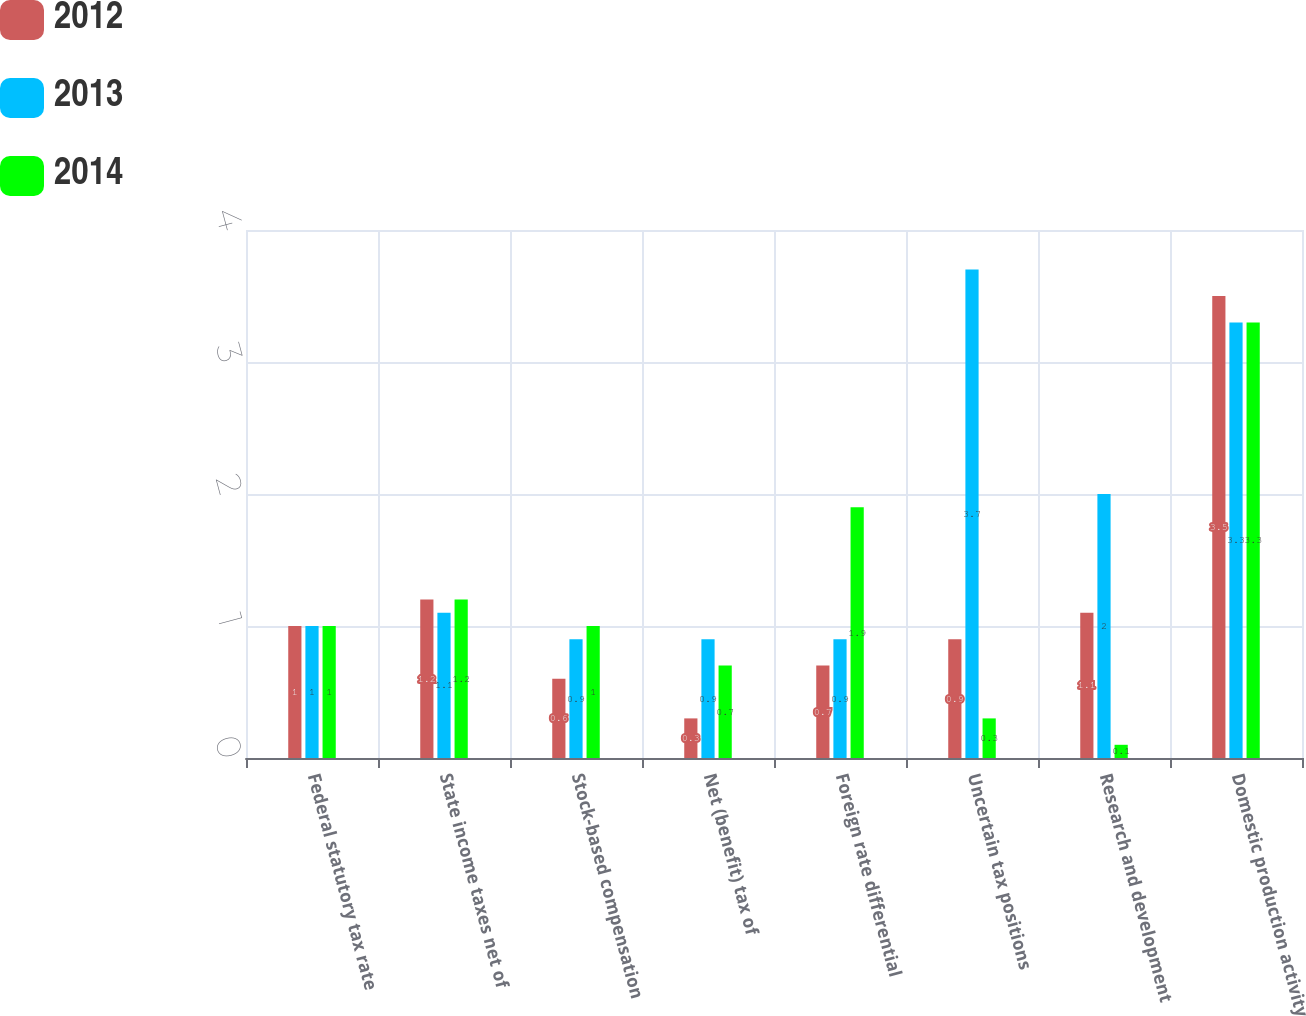Convert chart to OTSL. <chart><loc_0><loc_0><loc_500><loc_500><stacked_bar_chart><ecel><fcel>Federal statutory tax rate<fcel>State income taxes net of<fcel>Stock-based compensation<fcel>Net (benefit) tax of<fcel>Foreign rate differential<fcel>Uncertain tax positions<fcel>Research and development<fcel>Domestic production activity<nl><fcel>2012<fcel>1<fcel>1.2<fcel>0.6<fcel>0.3<fcel>0.7<fcel>0.9<fcel>1.1<fcel>3.5<nl><fcel>2013<fcel>1<fcel>1.1<fcel>0.9<fcel>0.9<fcel>0.9<fcel>3.7<fcel>2<fcel>3.3<nl><fcel>2014<fcel>1<fcel>1.2<fcel>1<fcel>0.7<fcel>1.9<fcel>0.3<fcel>0.1<fcel>3.3<nl></chart> 